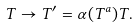<formula> <loc_0><loc_0><loc_500><loc_500>T \to T ^ { \prime } = \alpha ( T ^ { a } ) T .</formula> 